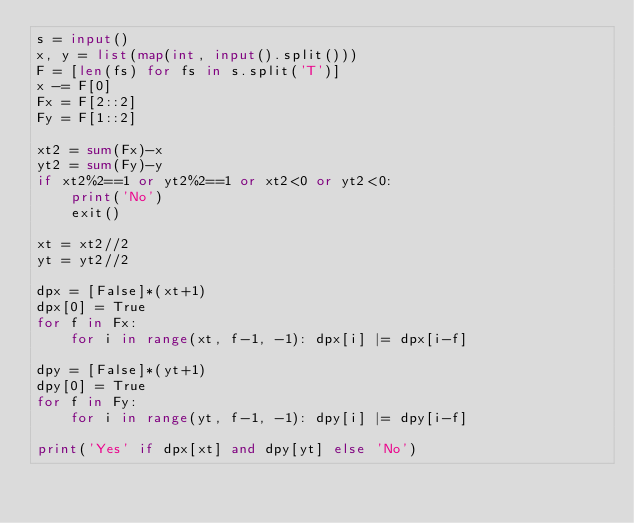<code> <loc_0><loc_0><loc_500><loc_500><_Python_>s = input()
x, y = list(map(int, input().split()))
F = [len(fs) for fs in s.split('T')]
x -= F[0]
Fx = F[2::2]
Fy = F[1::2]

xt2 = sum(Fx)-x
yt2 = sum(Fy)-y
if xt2%2==1 or yt2%2==1 or xt2<0 or yt2<0:
    print('No')
    exit()

xt = xt2//2
yt = yt2//2

dpx = [False]*(xt+1)
dpx[0] = True
for f in Fx:
    for i in range(xt, f-1, -1): dpx[i] |= dpx[i-f]

dpy = [False]*(yt+1)
dpy[0] = True
for f in Fy:
    for i in range(yt, f-1, -1): dpy[i] |= dpy[i-f]

print('Yes' if dpx[xt] and dpy[yt] else 'No')</code> 